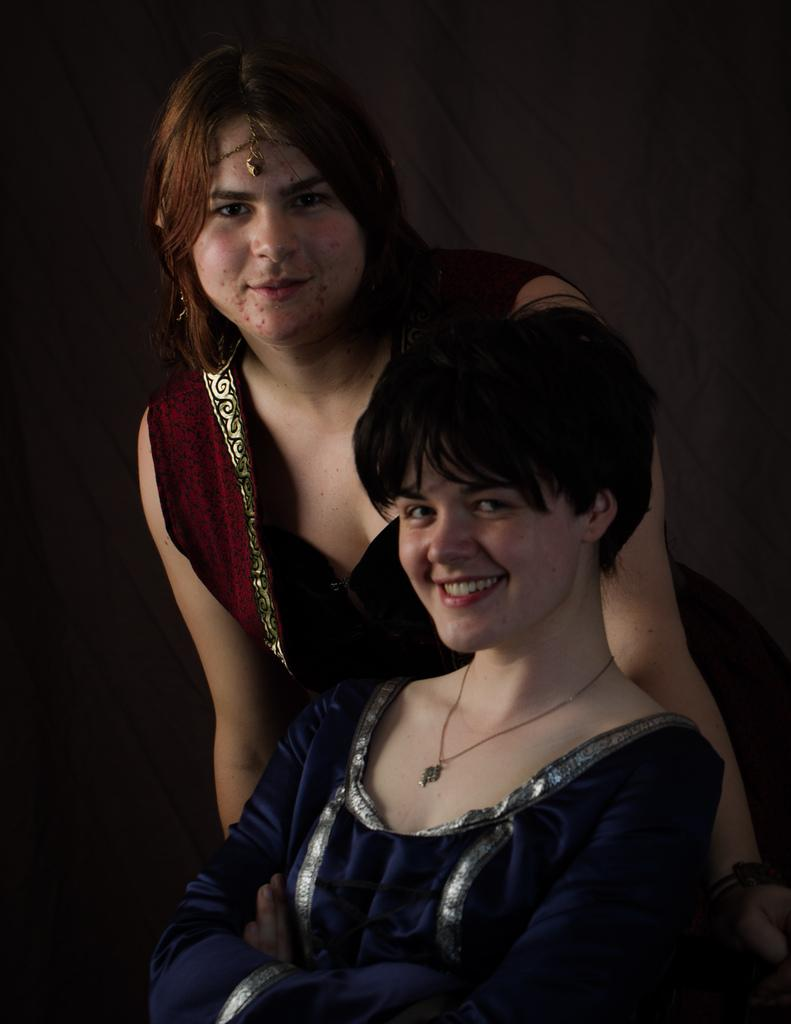How many people are in the image? There are two people in the image. What is the position of one of the people? One person is sitting. How is the other person positioned in relation to the sitting person? The other person is standing behind the sitting person. What type of pen is the toy using to write the dinner menu? There is no pen, toy, or dinner menu present in the image. 